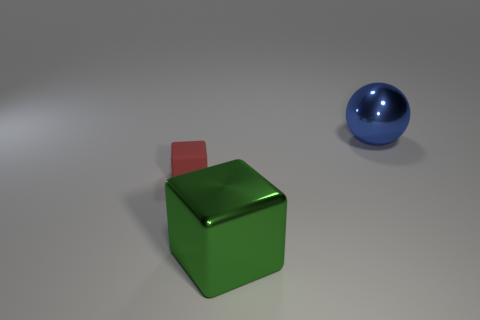The other thing that is the same size as the green thing is what shape?
Your response must be concise. Sphere. Are there an equal number of large green metal blocks behind the large blue shiny thing and metal cubes in front of the red object?
Ensure brevity in your answer.  No. There is a block to the left of the metallic object on the left side of the blue metal object; what size is it?
Make the answer very short. Small. Is there a blue metal sphere that has the same size as the green cube?
Your answer should be compact. Yes. There is a sphere that is the same material as the large green thing; what is its color?
Your answer should be compact. Blue. Is the number of red things less than the number of big red metal cubes?
Offer a very short reply. No. There is a thing that is right of the tiny object and behind the green shiny cube; what material is it made of?
Your answer should be very brief. Metal. There is a object in front of the small matte block; are there any blue spheres in front of it?
Offer a very short reply. No. Are the big sphere and the tiny cube made of the same material?
Your response must be concise. No. There is a big shiny ball; are there any large green cubes on the left side of it?
Ensure brevity in your answer.  Yes. 